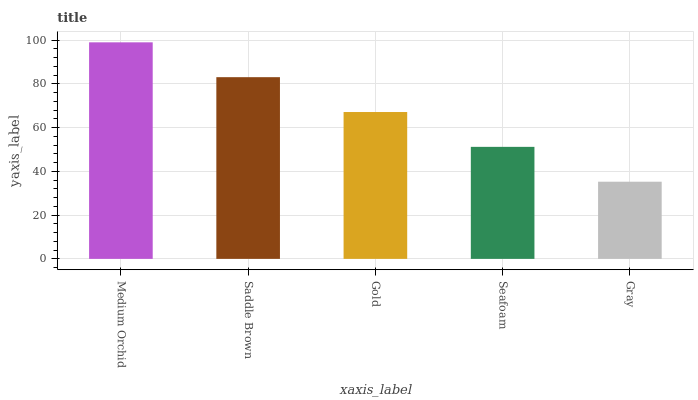Is Saddle Brown the minimum?
Answer yes or no. No. Is Saddle Brown the maximum?
Answer yes or no. No. Is Medium Orchid greater than Saddle Brown?
Answer yes or no. Yes. Is Saddle Brown less than Medium Orchid?
Answer yes or no. Yes. Is Saddle Brown greater than Medium Orchid?
Answer yes or no. No. Is Medium Orchid less than Saddle Brown?
Answer yes or no. No. Is Gold the high median?
Answer yes or no. Yes. Is Gold the low median?
Answer yes or no. Yes. Is Saddle Brown the high median?
Answer yes or no. No. Is Medium Orchid the low median?
Answer yes or no. No. 